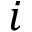Convert formula to latex. <formula><loc_0><loc_0><loc_500><loc_500>i</formula> 